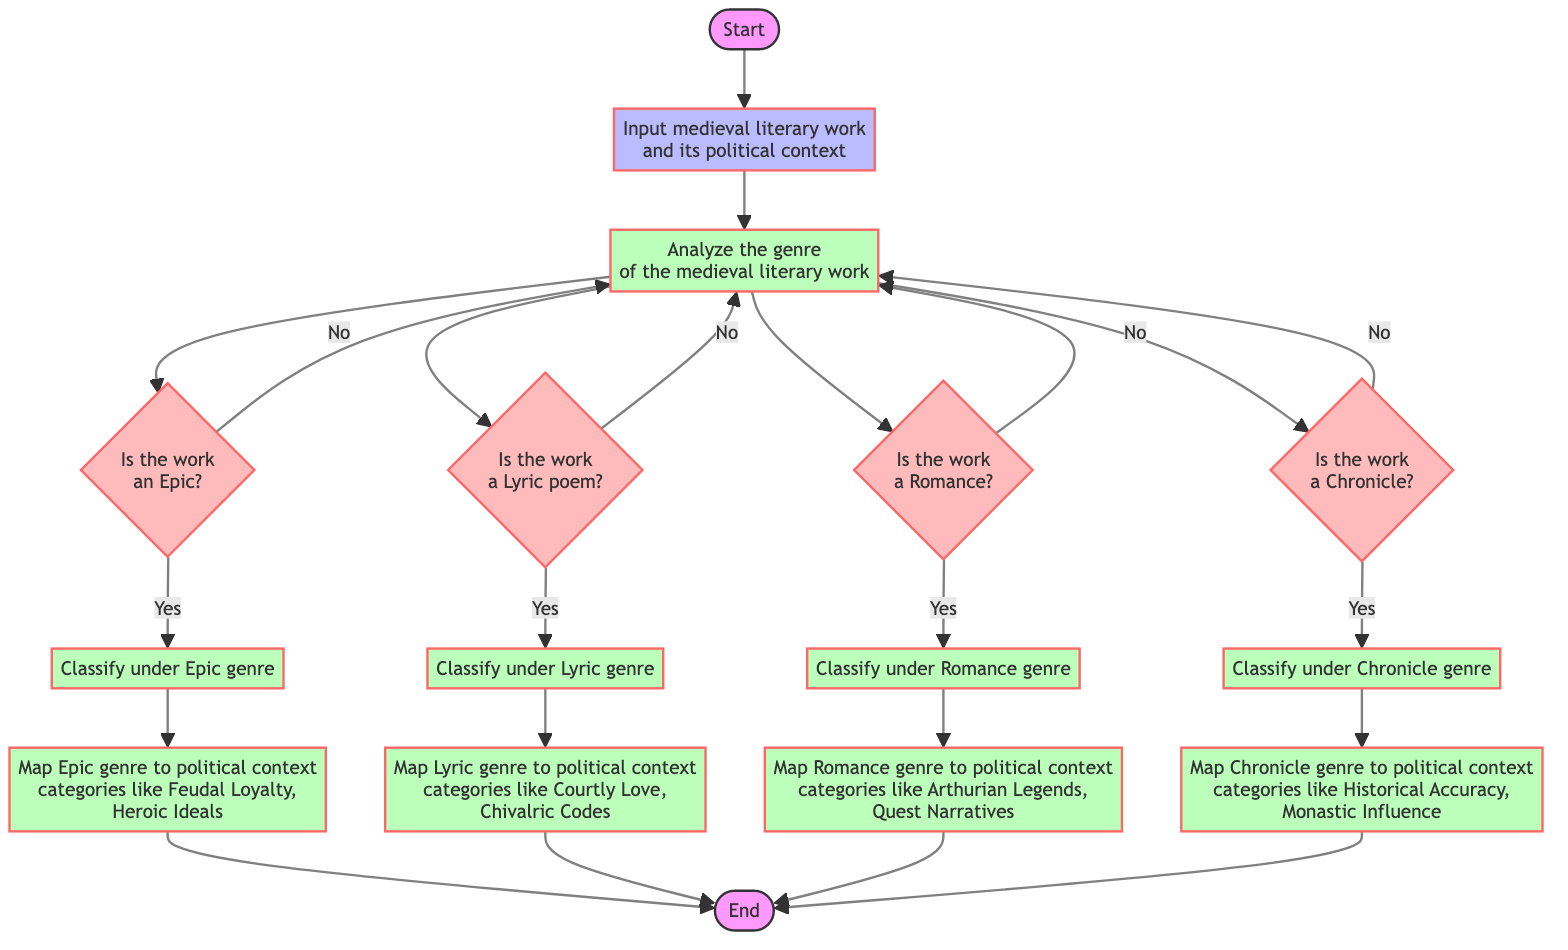What is the first step in the categorization process? The first step in the flowchart is labeled as "Start," indicating the initiation of the categorization process based on the political context.
Answer: Start How many decisions are made in the analysis of the genre? In the flowchart, there are four decisions: Identify Epic, Identify Lyric, Identify Romance, and Identify Chronicle.
Answer: Four What happens if the work is classified as a Chronicle? If the work is classified as a Chronicle, it proceeds to "Map Chronicle Context," which maps the Chronicle genre to specific political context categories like Historical Accuracy and Monastic Influence.
Answer: Map Chronicle Context Which political context categories are associated with the Epic genre? The Epic genre is associated with the political context categories such as Feudal Loyalty and Heroic Ideals as indicated in the mapping step.
Answer: Feudal Loyalty, Heroic Ideals What is the final step after mapping contexts for any genre? The final step after mapping the contexts for any genre is labeled as "End," which indicates that the categorization process is complete.
Answer: End What happens if a work does not fit into any genre category? If a work does not fit into any of the four genre categories (Epic, Lyric, Romance, Chronicle), it returns to the "Analyze Genre" process for further evaluation.
Answer: Analyze Genre How many processes lead to context mapping? Four processes lead to context mapping: Map Epic Context, Map Lyric Context, Map Romance Context, and Map Chronicle Context.
Answer: Four processes If a work is identified as a Lyric poem, which process follows? If a work is identified as a Lyric poem, the process that follows is "Classify under Lyric genre," which then leads to mapping its context.
Answer: Classify under Lyric genre 